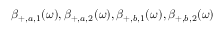<formula> <loc_0><loc_0><loc_500><loc_500>\beta _ { + , a , 1 } ( \omega ) , \beta _ { + , a , 2 } ( \omega ) , \beta _ { + , b , 1 } ( \omega ) , \beta _ { + , b , 2 } ( \omega )</formula> 